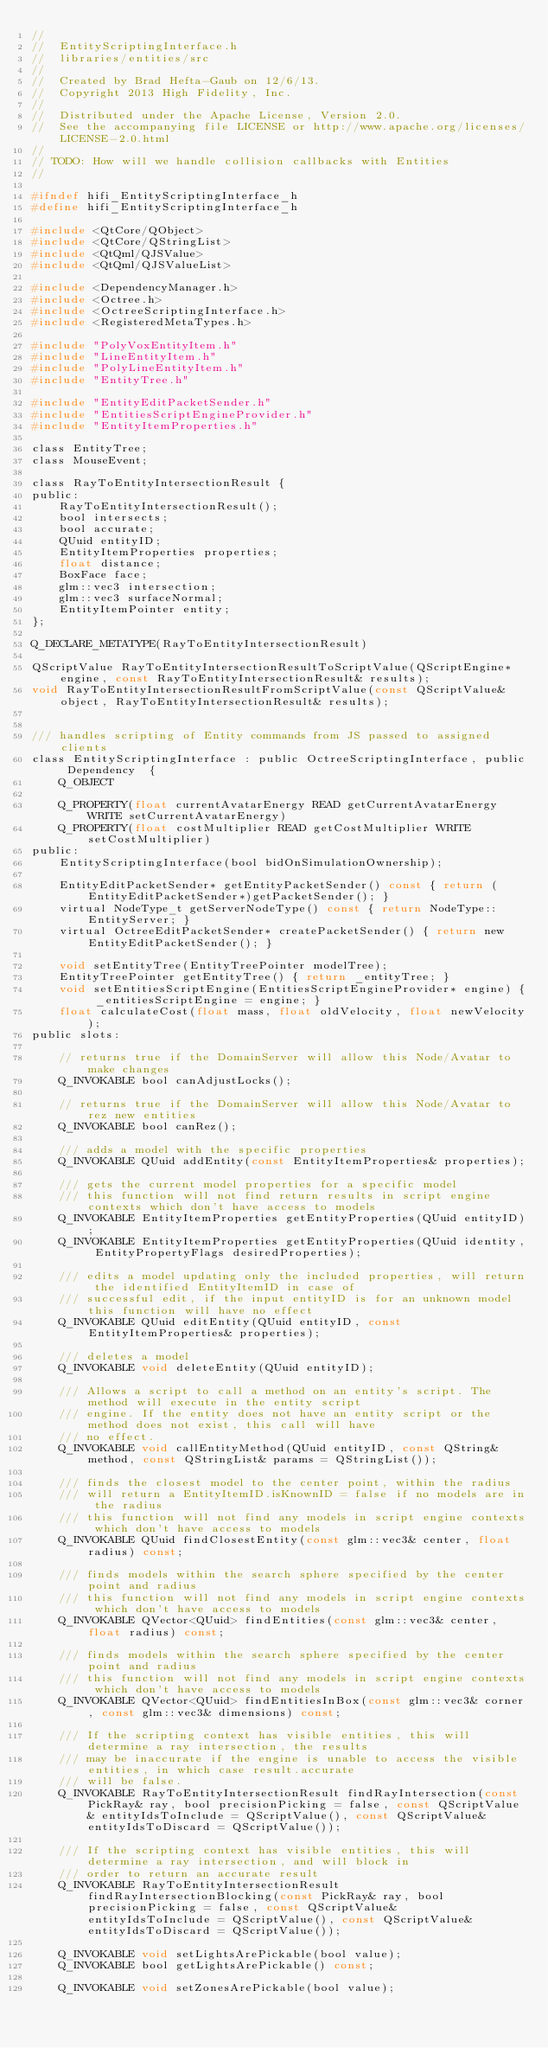Convert code to text. <code><loc_0><loc_0><loc_500><loc_500><_C_>//
//  EntityScriptingInterface.h
//  libraries/entities/src
//
//  Created by Brad Hefta-Gaub on 12/6/13.
//  Copyright 2013 High Fidelity, Inc.
//
//  Distributed under the Apache License, Version 2.0.
//  See the accompanying file LICENSE or http://www.apache.org/licenses/LICENSE-2.0.html
//
// TODO: How will we handle collision callbacks with Entities
//

#ifndef hifi_EntityScriptingInterface_h
#define hifi_EntityScriptingInterface_h

#include <QtCore/QObject>
#include <QtCore/QStringList>
#include <QtQml/QJSValue>
#include <QtQml/QJSValueList>

#include <DependencyManager.h>
#include <Octree.h>
#include <OctreeScriptingInterface.h>
#include <RegisteredMetaTypes.h>

#include "PolyVoxEntityItem.h"
#include "LineEntityItem.h"
#include "PolyLineEntityItem.h"
#include "EntityTree.h"

#include "EntityEditPacketSender.h"
#include "EntitiesScriptEngineProvider.h"
#include "EntityItemProperties.h"

class EntityTree;
class MouseEvent;

class RayToEntityIntersectionResult {
public:
    RayToEntityIntersectionResult();
    bool intersects;
    bool accurate;
    QUuid entityID;
    EntityItemProperties properties;
    float distance;
    BoxFace face;
    glm::vec3 intersection;
    glm::vec3 surfaceNormal;
    EntityItemPointer entity;
};

Q_DECLARE_METATYPE(RayToEntityIntersectionResult)

QScriptValue RayToEntityIntersectionResultToScriptValue(QScriptEngine* engine, const RayToEntityIntersectionResult& results);
void RayToEntityIntersectionResultFromScriptValue(const QScriptValue& object, RayToEntityIntersectionResult& results);


/// handles scripting of Entity commands from JS passed to assigned clients
class EntityScriptingInterface : public OctreeScriptingInterface, public Dependency  {
    Q_OBJECT
    
    Q_PROPERTY(float currentAvatarEnergy READ getCurrentAvatarEnergy WRITE setCurrentAvatarEnergy)
    Q_PROPERTY(float costMultiplier READ getCostMultiplier WRITE setCostMultiplier)
public:
    EntityScriptingInterface(bool bidOnSimulationOwnership);

    EntityEditPacketSender* getEntityPacketSender() const { return (EntityEditPacketSender*)getPacketSender(); }
    virtual NodeType_t getServerNodeType() const { return NodeType::EntityServer; }
    virtual OctreeEditPacketSender* createPacketSender() { return new EntityEditPacketSender(); }

    void setEntityTree(EntityTreePointer modelTree);
    EntityTreePointer getEntityTree() { return _entityTree; }
    void setEntitiesScriptEngine(EntitiesScriptEngineProvider* engine) { _entitiesScriptEngine = engine; }
    float calculateCost(float mass, float oldVelocity, float newVelocity);
public slots:

    // returns true if the DomainServer will allow this Node/Avatar to make changes
    Q_INVOKABLE bool canAdjustLocks();

    // returns true if the DomainServer will allow this Node/Avatar to rez new entities
    Q_INVOKABLE bool canRez();

    /// adds a model with the specific properties
    Q_INVOKABLE QUuid addEntity(const EntityItemProperties& properties);

    /// gets the current model properties for a specific model
    /// this function will not find return results in script engine contexts which don't have access to models
    Q_INVOKABLE EntityItemProperties getEntityProperties(QUuid entityID);
    Q_INVOKABLE EntityItemProperties getEntityProperties(QUuid identity, EntityPropertyFlags desiredProperties);

    /// edits a model updating only the included properties, will return the identified EntityItemID in case of
    /// successful edit, if the input entityID is for an unknown model this function will have no effect
    Q_INVOKABLE QUuid editEntity(QUuid entityID, const EntityItemProperties& properties);

    /// deletes a model
    Q_INVOKABLE void deleteEntity(QUuid entityID);

    /// Allows a script to call a method on an entity's script. The method will execute in the entity script
    /// engine. If the entity does not have an entity script or the method does not exist, this call will have
    /// no effect.
    Q_INVOKABLE void callEntityMethod(QUuid entityID, const QString& method, const QStringList& params = QStringList());

    /// finds the closest model to the center point, within the radius
    /// will return a EntityItemID.isKnownID = false if no models are in the radius
    /// this function will not find any models in script engine contexts which don't have access to models
    Q_INVOKABLE QUuid findClosestEntity(const glm::vec3& center, float radius) const;

    /// finds models within the search sphere specified by the center point and radius
    /// this function will not find any models in script engine contexts which don't have access to models
    Q_INVOKABLE QVector<QUuid> findEntities(const glm::vec3& center, float radius) const;

    /// finds models within the search sphere specified by the center point and radius
    /// this function will not find any models in script engine contexts which don't have access to models
    Q_INVOKABLE QVector<QUuid> findEntitiesInBox(const glm::vec3& corner, const glm::vec3& dimensions) const;

    /// If the scripting context has visible entities, this will determine a ray intersection, the results
    /// may be inaccurate if the engine is unable to access the visible entities, in which case result.accurate
    /// will be false.
    Q_INVOKABLE RayToEntityIntersectionResult findRayIntersection(const PickRay& ray, bool precisionPicking = false, const QScriptValue& entityIdsToInclude = QScriptValue(), const QScriptValue& entityIdsToDiscard = QScriptValue());

    /// If the scripting context has visible entities, this will determine a ray intersection, and will block in
    /// order to return an accurate result
    Q_INVOKABLE RayToEntityIntersectionResult findRayIntersectionBlocking(const PickRay& ray, bool precisionPicking = false, const QScriptValue& entityIdsToInclude = QScriptValue(), const QScriptValue& entityIdsToDiscard = QScriptValue());

    Q_INVOKABLE void setLightsArePickable(bool value);
    Q_INVOKABLE bool getLightsArePickable() const;

    Q_INVOKABLE void setZonesArePickable(bool value);</code> 